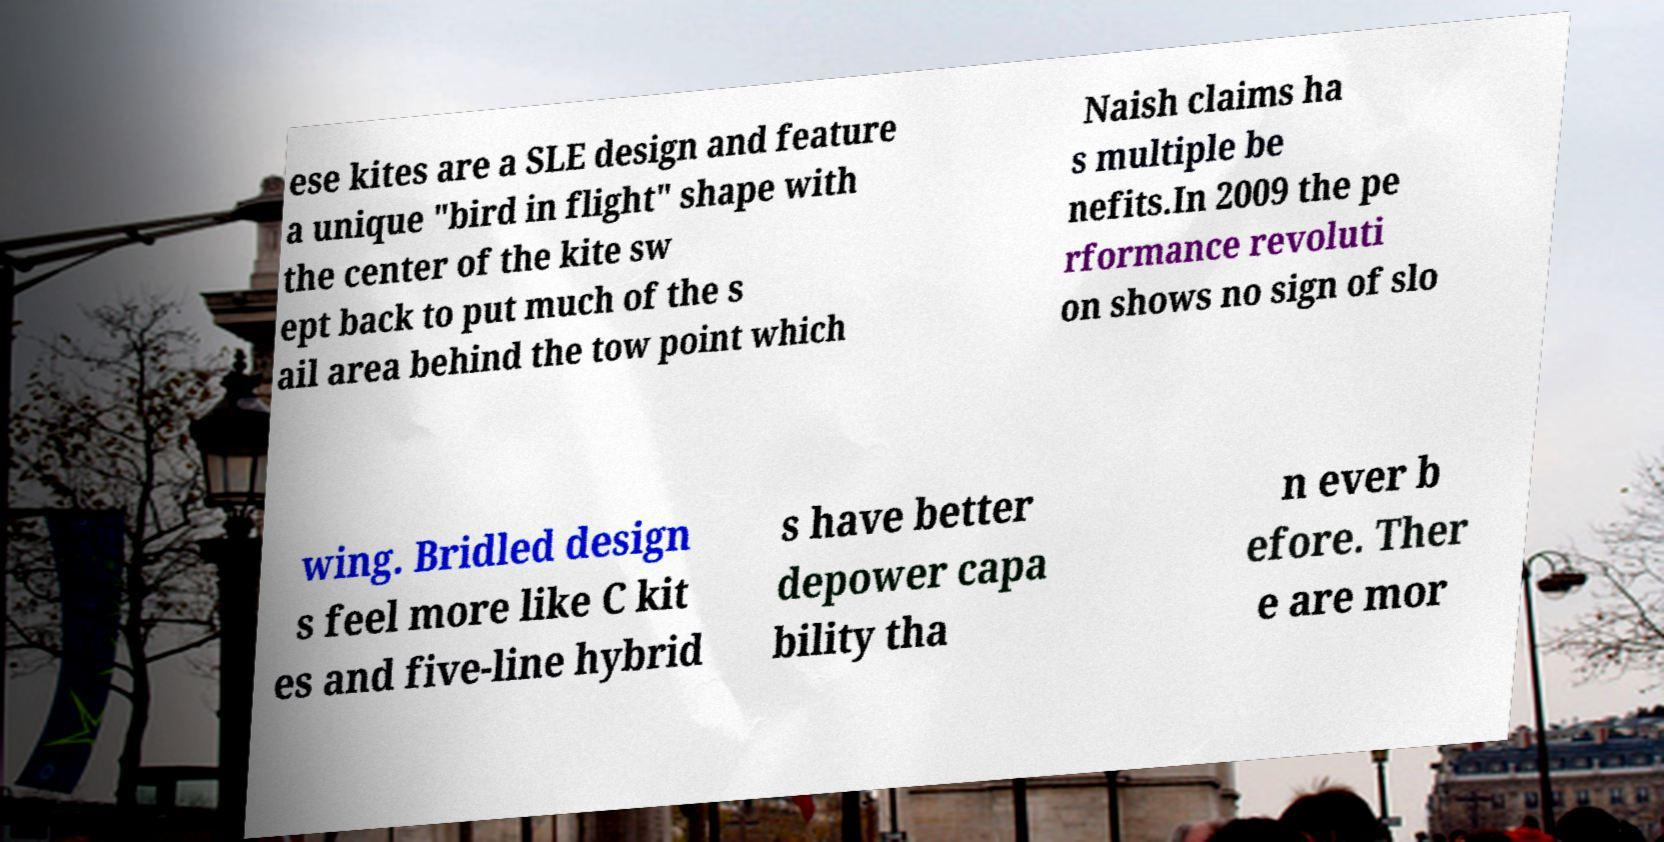There's text embedded in this image that I need extracted. Can you transcribe it verbatim? ese kites are a SLE design and feature a unique "bird in flight" shape with the center of the kite sw ept back to put much of the s ail area behind the tow point which Naish claims ha s multiple be nefits.In 2009 the pe rformance revoluti on shows no sign of slo wing. Bridled design s feel more like C kit es and five-line hybrid s have better depower capa bility tha n ever b efore. Ther e are mor 